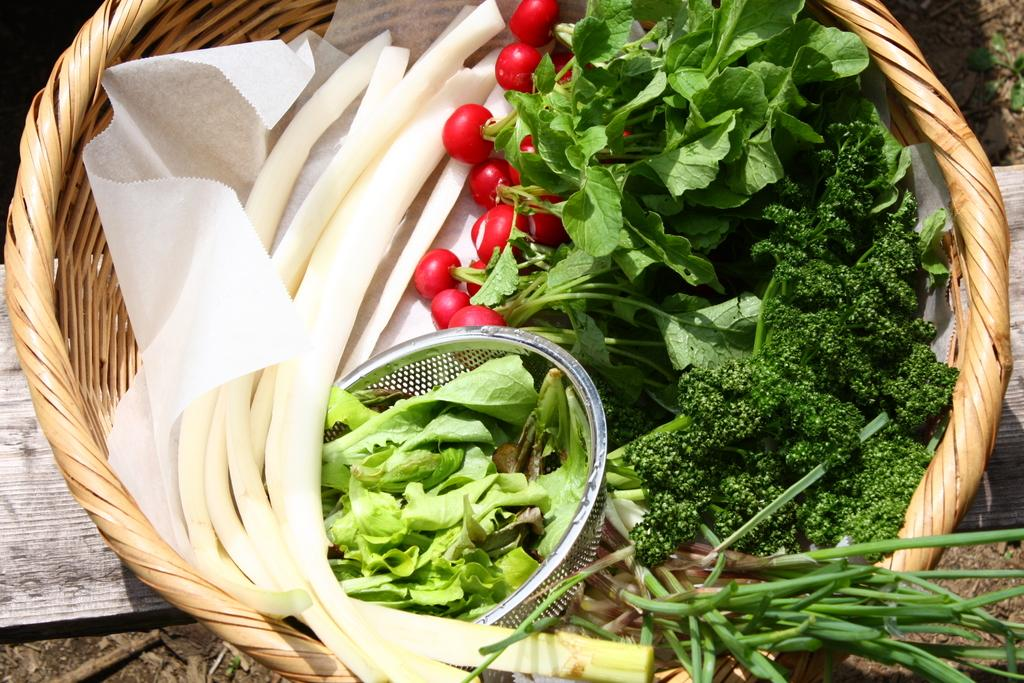What type of food items are in the basket in the image? There are vegetables in a basket in the image. What is located at the bottom of the image? There is a wooden board at the bottom of the image. What type of machine can be seen operating in the background of the image? There is no machine present in the image; it only features a basket of vegetables and a wooden board. 